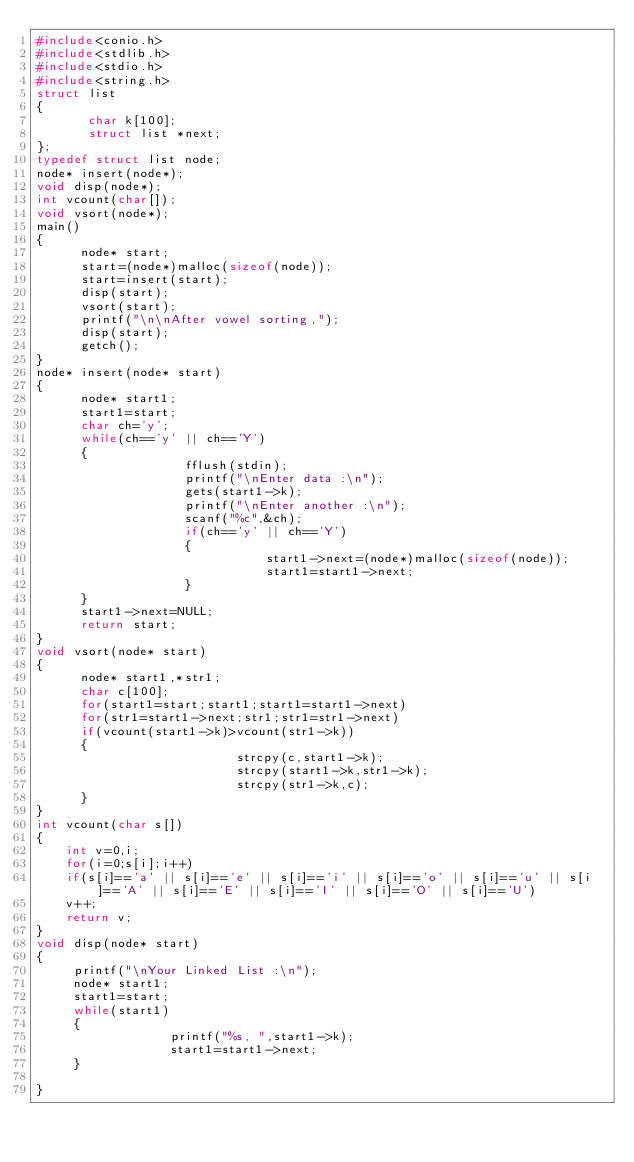Convert code to text. <code><loc_0><loc_0><loc_500><loc_500><_C++_>#include<conio.h>
#include<stdlib.h>
#include<stdio.h>
#include<string.h>
struct list
{
       char k[100];
       struct list *next;
};
typedef struct list node;
node* insert(node*);
void disp(node*);
int vcount(char[]);
void vsort(node*);
main()
{
      node* start;
      start=(node*)malloc(sizeof(node));
      start=insert(start);
      disp(start);
      vsort(start);
      printf("\n\nAfter vowel sorting,");
      disp(start);
      getch();
}
node* insert(node* start)
{
      node* start1;
      start1=start;
      char ch='y';
      while(ch=='y' || ch=='Y')
      {
                    fflush(stdin);
                    printf("\nEnter data :\n");
                    gets(start1->k);
                    printf("\nEnter another :\n");
                    scanf("%c",&ch);
                    if(ch=='y' || ch=='Y')
                    {
                               start1->next=(node*)malloc(sizeof(node));
                               start1=start1->next;
                    }
      }
      start1->next=NULL;
      return start;
}
void vsort(node* start)
{
      node* start1,*str1;
      char c[100];
      for(start1=start;start1;start1=start1->next)
      for(str1=start1->next;str1;str1=str1->next)
      if(vcount(start1->k)>vcount(str1->k))
      {
                           strcpy(c,start1->k);
                           strcpy(start1->k,str1->k);
                           strcpy(str1->k,c);
      }
}
int vcount(char s[])
{
    int v=0,i;
    for(i=0;s[i];i++)
    if(s[i]=='a' || s[i]=='e' || s[i]=='i' || s[i]=='o' || s[i]=='u' || s[i]=='A' || s[i]=='E' || s[i]=='I' || s[i]=='O' || s[i]=='U')
    v++;
    return v;
}
void disp(node* start)
{
     printf("\nYour Linked List :\n");
     node* start1;
     start1=start;
     while(start1)
     {
                  printf("%s, ",start1->k);
                  start1=start1->next;
     }
     
}
</code> 